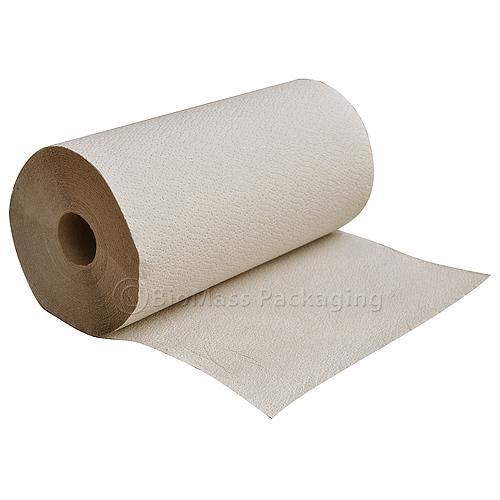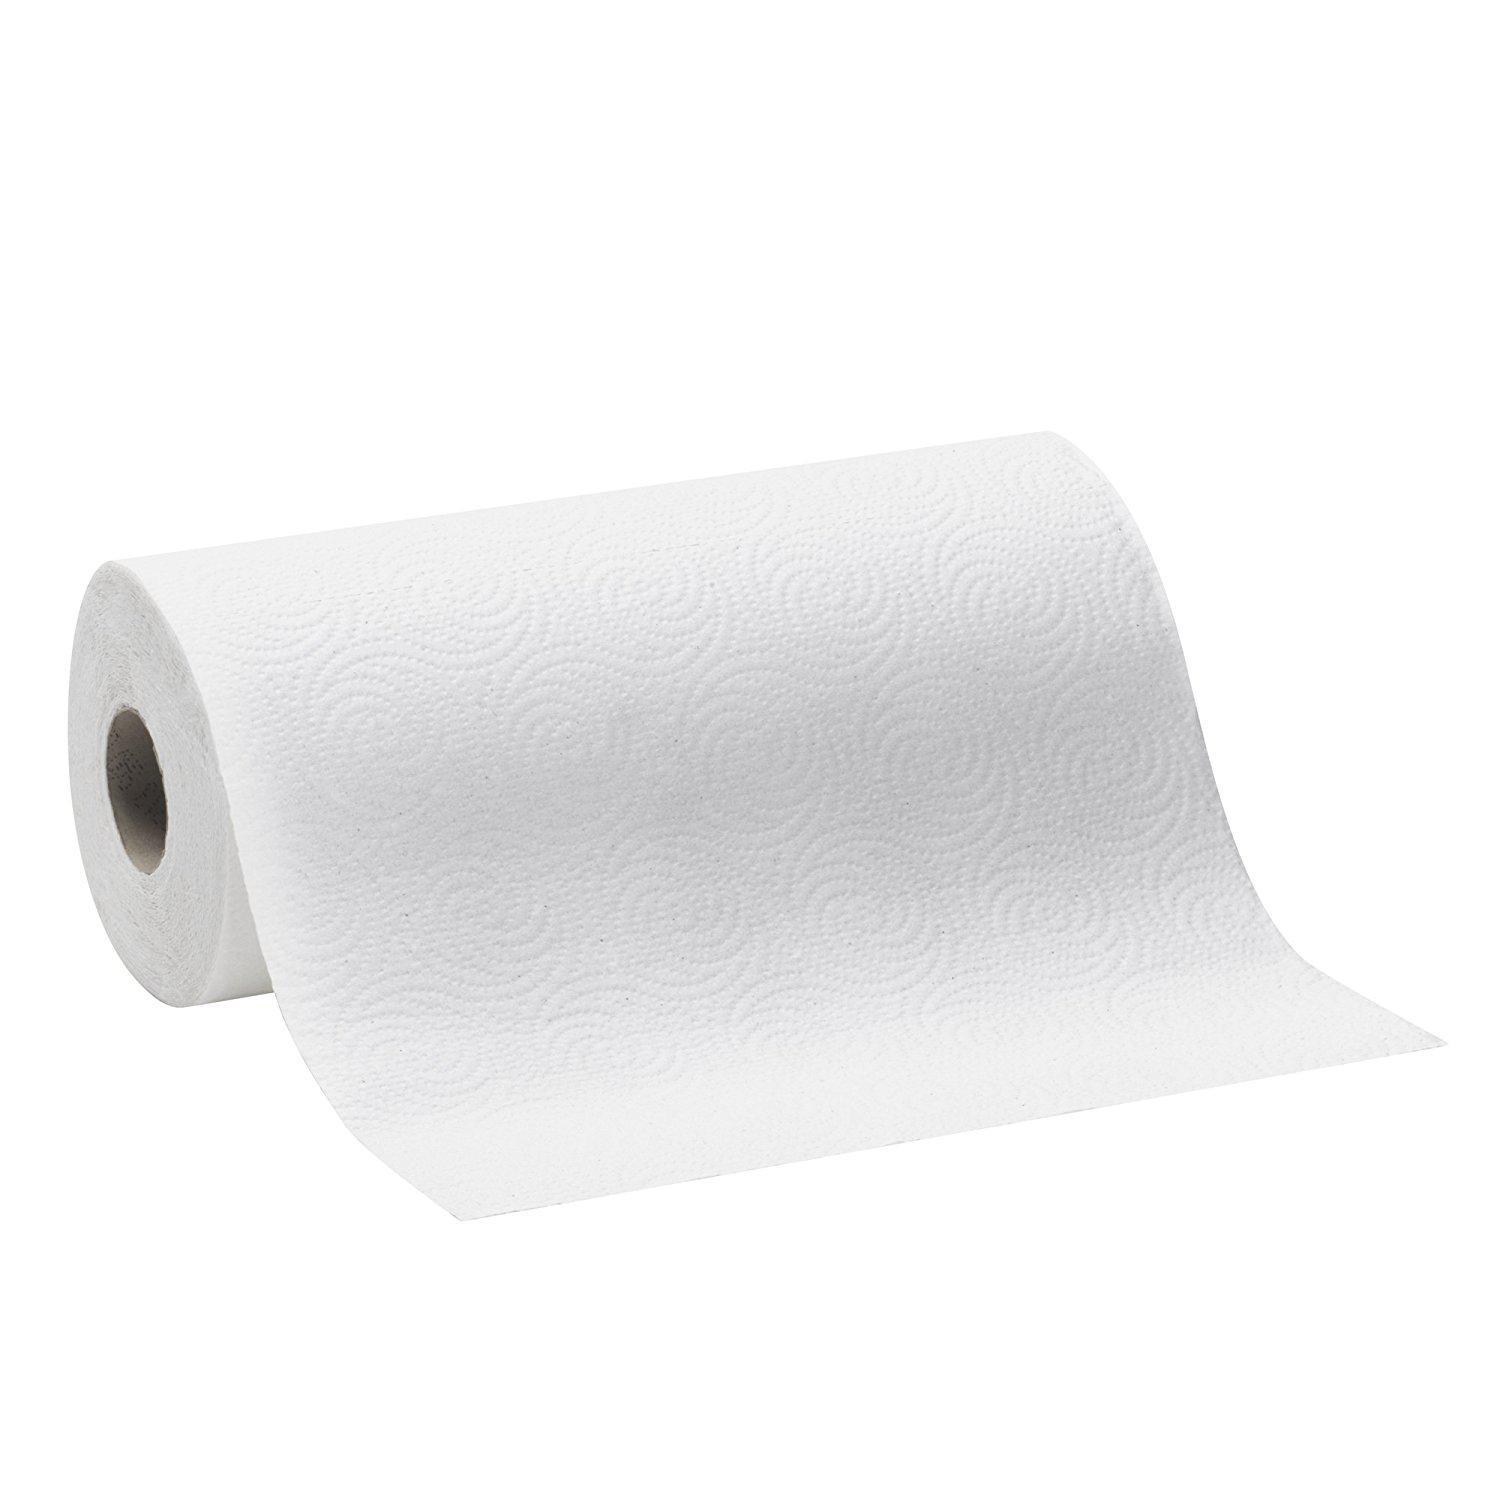The first image is the image on the left, the second image is the image on the right. Given the left and right images, does the statement "One roll of tan and one roll of white paper towels are laying horizontally." hold true? Answer yes or no. Yes. The first image is the image on the left, the second image is the image on the right. Assess this claim about the two images: "1 roll is unrolling from the top.". Correct or not? Answer yes or no. Yes. 